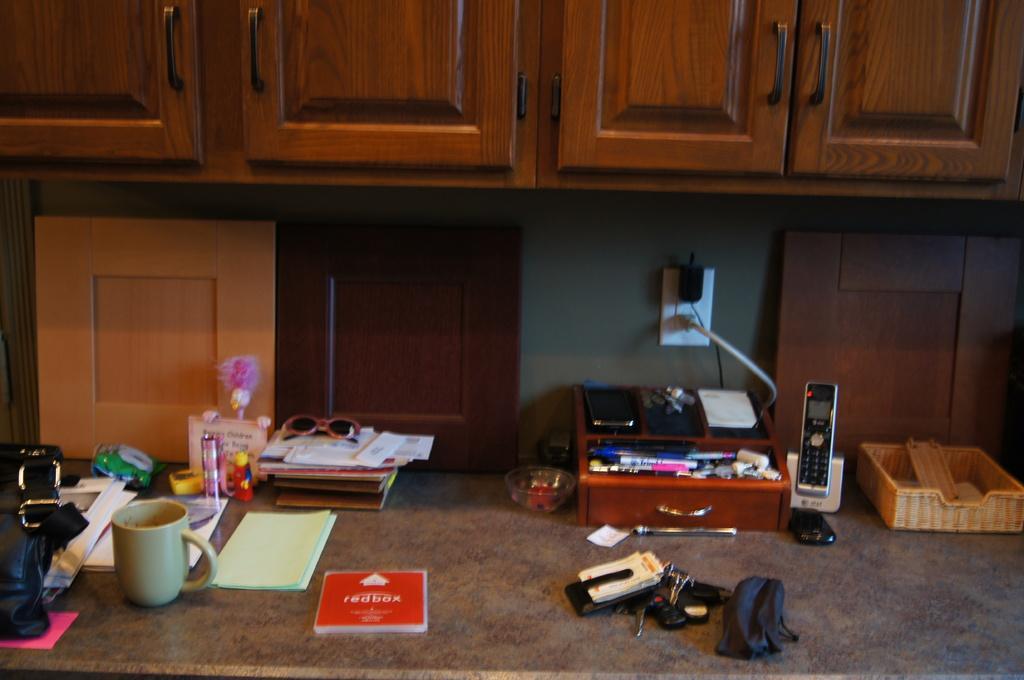How would you summarize this image in a sentence or two? In this image I can see a cup, shades, books and some other objects on a surface. Here I can see wooden cupboards and some other objects attached to the wall. 